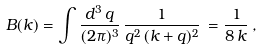Convert formula to latex. <formula><loc_0><loc_0><loc_500><loc_500>B ( k ) = \int \frac { d ^ { 3 } \, q } { ( 2 \pi ) ^ { 3 } } \, \frac { 1 } { q ^ { 2 } \, ( { k } + { q } ) ^ { 2 } } \, = \frac { 1 } { 8 \, k } \, ,</formula> 